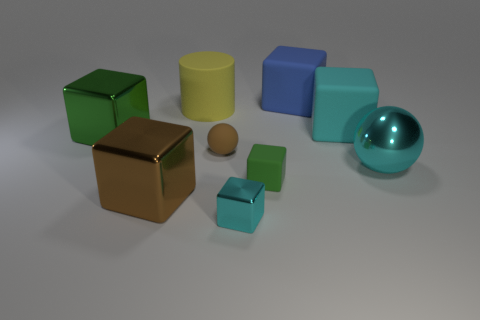Is the material of the large thing in front of the large cyan ball the same as the cube behind the cyan matte cube?
Give a very brief answer. No. There is a cyan thing that is both to the left of the big metal sphere and behind the small green rubber block; what is its material?
Keep it short and to the point. Rubber. What is the material of the large green object?
Keep it short and to the point. Metal. There is a large yellow rubber cylinder; how many tiny cyan objects are on the left side of it?
Provide a succinct answer. 0. Is the large block behind the big yellow rubber thing made of the same material as the large yellow object?
Offer a very short reply. Yes. What number of small matte objects have the same shape as the small metal object?
Your answer should be compact. 1. How many large objects are yellow metal cylinders or cyan shiny cubes?
Ensure brevity in your answer.  0. Does the large shiny block that is behind the brown sphere have the same color as the tiny rubber block?
Give a very brief answer. Yes. Is the color of the matte cube that is left of the big blue matte thing the same as the shiny cube that is on the left side of the large brown thing?
Your response must be concise. Yes. Is there a large yellow object that has the same material as the tiny brown sphere?
Your response must be concise. Yes. 